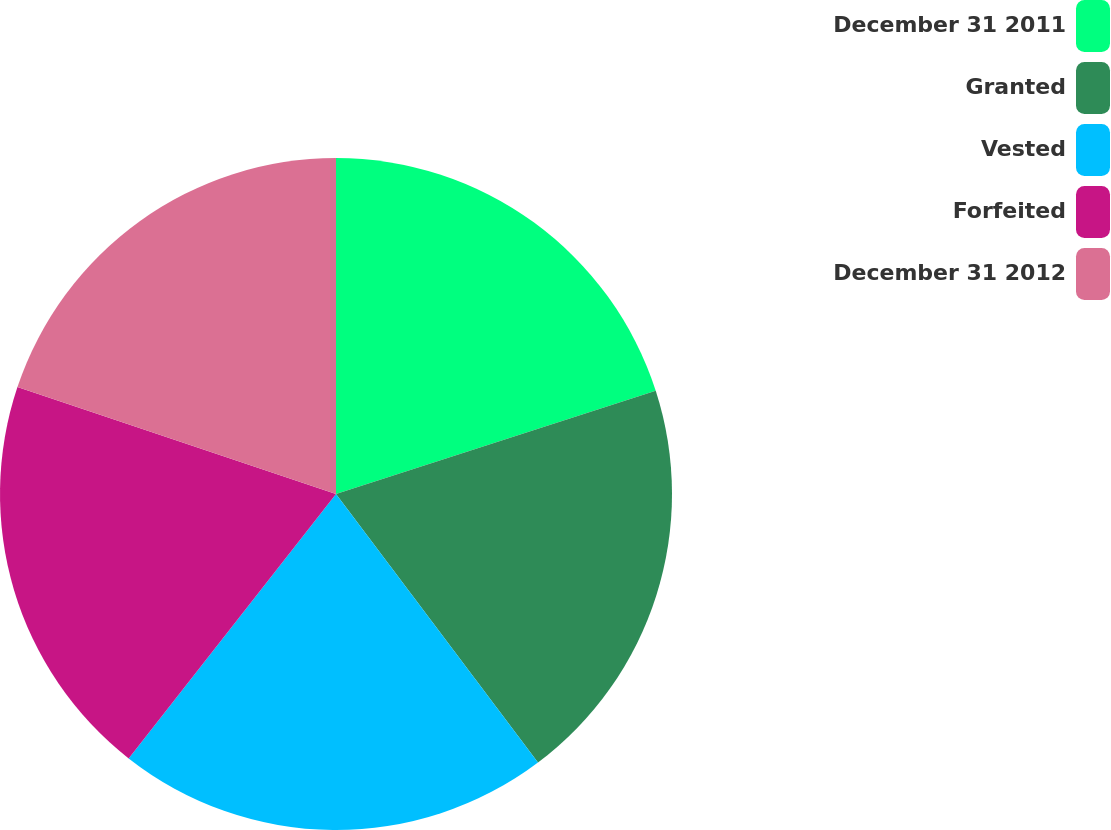Convert chart to OTSL. <chart><loc_0><loc_0><loc_500><loc_500><pie_chart><fcel>December 31 2011<fcel>Granted<fcel>Vested<fcel>Forfeited<fcel>December 31 2012<nl><fcel>20.03%<fcel>19.71%<fcel>20.85%<fcel>19.57%<fcel>19.85%<nl></chart> 